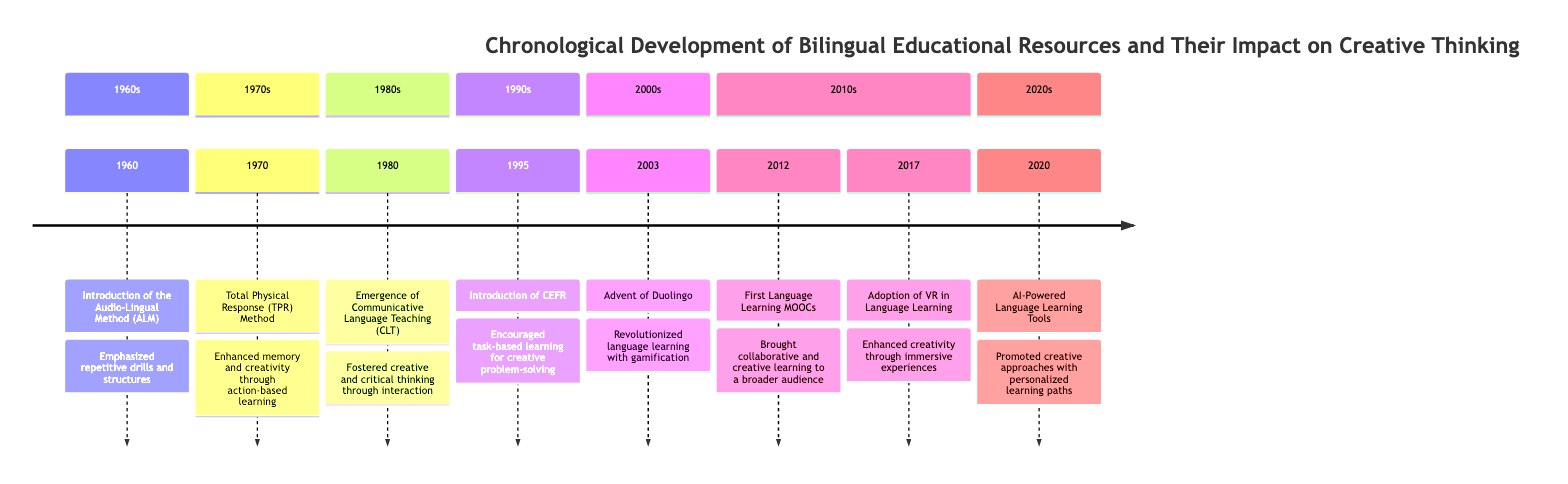What event was introduced in 1960? The diagram shows that the event introduced in 1960 is the "Introduction of the Audio-Lingual Method (ALM)." It is positioned at the beginning of the timeline, indicating it was the first event listed.
Answer: Introduction of the Audio-Lingual Method (ALM) What teaching method was developed in 1970? The timeline reveals that the method developed in 1970 is the "Total Physical Response (TPR) Method." It is specifically mentioned next to the year 1970 as part of the events listed.
Answer: Total Physical Response (TPR) Method How many major educational resources are presented in the timeline? By counting each event in the timeline, there are eight distinct educational resources/events listed from 1960 to 2020. Each point on the timeline corresponds to a unique educational resource.
Answer: 8 Which method emerged in the 1980s that fosters creative thinking? The diagram states that "Communicative Language Teaching (CLT)" emerged in 1980. This teaching method promotes spontaneous use of language, thus fostering creative thinking.
Answer: Communicative Language Teaching (CLT) Which online platform was launched in 2003? Referring to the timeline, the online platform launched in 2003 is "Duolingo." It is explicitly stated next to the year 2003, making it easy to identify.
Answer: Duolingo Which event in the 2010s focused on language learning through immersive experiences? The timeline indicates that the "Adoption of Virtual Reality (VR) in Language Learning" occurred in 2017 and is noted as enhancing creativity through immersive experiences. This shows the specific focus on immersive experiences.
Answer: Adoption of Virtual Reality (VR) in Language Learning What framework was introduced in 1995? According to the timeline, the "Common European Framework of Reference for Languages (CEFR)" was introduced in 1995. It is positioned clearly in the timeline to signify its introduction year.
Answer: Common European Framework of Reference for Languages (CEFR) Which resources emphasize task-based learning for creative problem-solving? The timeline shows that the "Introduction of the CEFR" in 1995 encouraged task-based learning that enhances creative problem-solving. This indicates a direct link between the resource and its educational approach.
Answer: Introduction of the CEFR 